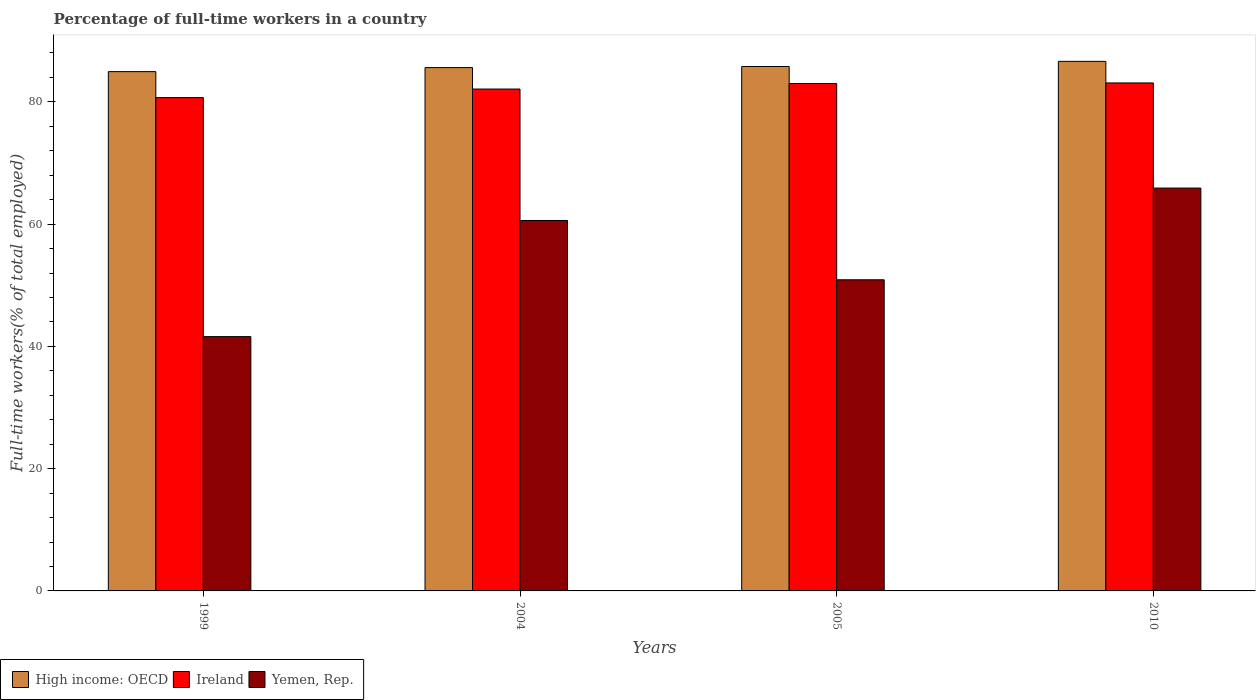How many different coloured bars are there?
Keep it short and to the point. 3. How many groups of bars are there?
Offer a terse response. 4. Are the number of bars on each tick of the X-axis equal?
Offer a terse response. Yes. How many bars are there on the 1st tick from the right?
Keep it short and to the point. 3. In how many cases, is the number of bars for a given year not equal to the number of legend labels?
Offer a terse response. 0. What is the percentage of full-time workers in Ireland in 2004?
Give a very brief answer. 82.1. Across all years, what is the maximum percentage of full-time workers in High income: OECD?
Provide a short and direct response. 86.63. Across all years, what is the minimum percentage of full-time workers in Ireland?
Your answer should be very brief. 80.7. In which year was the percentage of full-time workers in High income: OECD minimum?
Your answer should be compact. 1999. What is the total percentage of full-time workers in Yemen, Rep. in the graph?
Keep it short and to the point. 219. What is the difference between the percentage of full-time workers in Ireland in 1999 and that in 2010?
Offer a terse response. -2.4. What is the difference between the percentage of full-time workers in Ireland in 2005 and the percentage of full-time workers in High income: OECD in 1999?
Provide a succinct answer. -1.95. What is the average percentage of full-time workers in High income: OECD per year?
Offer a very short reply. 85.74. In the year 1999, what is the difference between the percentage of full-time workers in Ireland and percentage of full-time workers in High income: OECD?
Your answer should be very brief. -4.25. In how many years, is the percentage of full-time workers in Ireland greater than 8 %?
Offer a terse response. 4. What is the ratio of the percentage of full-time workers in High income: OECD in 1999 to that in 2010?
Give a very brief answer. 0.98. Is the difference between the percentage of full-time workers in Ireland in 2005 and 2010 greater than the difference between the percentage of full-time workers in High income: OECD in 2005 and 2010?
Your response must be concise. Yes. What is the difference between the highest and the second highest percentage of full-time workers in Ireland?
Provide a short and direct response. 0.1. What is the difference between the highest and the lowest percentage of full-time workers in Yemen, Rep.?
Ensure brevity in your answer.  24.3. What does the 3rd bar from the left in 2010 represents?
Offer a very short reply. Yemen, Rep. What does the 3rd bar from the right in 2005 represents?
Offer a terse response. High income: OECD. What is the difference between two consecutive major ticks on the Y-axis?
Ensure brevity in your answer.  20. Are the values on the major ticks of Y-axis written in scientific E-notation?
Provide a succinct answer. No. Does the graph contain grids?
Ensure brevity in your answer.  No. How are the legend labels stacked?
Keep it short and to the point. Horizontal. What is the title of the graph?
Provide a succinct answer. Percentage of full-time workers in a country. Does "Nicaragua" appear as one of the legend labels in the graph?
Make the answer very short. No. What is the label or title of the X-axis?
Provide a short and direct response. Years. What is the label or title of the Y-axis?
Make the answer very short. Full-time workers(% of total employed). What is the Full-time workers(% of total employed) of High income: OECD in 1999?
Your response must be concise. 84.95. What is the Full-time workers(% of total employed) in Ireland in 1999?
Offer a terse response. 80.7. What is the Full-time workers(% of total employed) in Yemen, Rep. in 1999?
Offer a terse response. 41.6. What is the Full-time workers(% of total employed) in High income: OECD in 2004?
Ensure brevity in your answer.  85.61. What is the Full-time workers(% of total employed) in Ireland in 2004?
Make the answer very short. 82.1. What is the Full-time workers(% of total employed) in Yemen, Rep. in 2004?
Ensure brevity in your answer.  60.6. What is the Full-time workers(% of total employed) in High income: OECD in 2005?
Keep it short and to the point. 85.79. What is the Full-time workers(% of total employed) in Yemen, Rep. in 2005?
Offer a very short reply. 50.9. What is the Full-time workers(% of total employed) in High income: OECD in 2010?
Give a very brief answer. 86.63. What is the Full-time workers(% of total employed) of Ireland in 2010?
Provide a succinct answer. 83.1. What is the Full-time workers(% of total employed) in Yemen, Rep. in 2010?
Your answer should be compact. 65.9. Across all years, what is the maximum Full-time workers(% of total employed) in High income: OECD?
Give a very brief answer. 86.63. Across all years, what is the maximum Full-time workers(% of total employed) of Ireland?
Give a very brief answer. 83.1. Across all years, what is the maximum Full-time workers(% of total employed) of Yemen, Rep.?
Provide a succinct answer. 65.9. Across all years, what is the minimum Full-time workers(% of total employed) in High income: OECD?
Keep it short and to the point. 84.95. Across all years, what is the minimum Full-time workers(% of total employed) of Ireland?
Keep it short and to the point. 80.7. Across all years, what is the minimum Full-time workers(% of total employed) in Yemen, Rep.?
Your response must be concise. 41.6. What is the total Full-time workers(% of total employed) in High income: OECD in the graph?
Provide a short and direct response. 342.97. What is the total Full-time workers(% of total employed) of Ireland in the graph?
Keep it short and to the point. 328.9. What is the total Full-time workers(% of total employed) of Yemen, Rep. in the graph?
Offer a very short reply. 219. What is the difference between the Full-time workers(% of total employed) of High income: OECD in 1999 and that in 2004?
Ensure brevity in your answer.  -0.66. What is the difference between the Full-time workers(% of total employed) of Yemen, Rep. in 1999 and that in 2004?
Your answer should be very brief. -19. What is the difference between the Full-time workers(% of total employed) in High income: OECD in 1999 and that in 2005?
Your response must be concise. -0.84. What is the difference between the Full-time workers(% of total employed) of Ireland in 1999 and that in 2005?
Make the answer very short. -2.3. What is the difference between the Full-time workers(% of total employed) in Yemen, Rep. in 1999 and that in 2005?
Your answer should be very brief. -9.3. What is the difference between the Full-time workers(% of total employed) in High income: OECD in 1999 and that in 2010?
Your answer should be very brief. -1.68. What is the difference between the Full-time workers(% of total employed) in Ireland in 1999 and that in 2010?
Make the answer very short. -2.4. What is the difference between the Full-time workers(% of total employed) in Yemen, Rep. in 1999 and that in 2010?
Your answer should be very brief. -24.3. What is the difference between the Full-time workers(% of total employed) in High income: OECD in 2004 and that in 2005?
Your response must be concise. -0.18. What is the difference between the Full-time workers(% of total employed) of Ireland in 2004 and that in 2005?
Offer a very short reply. -0.9. What is the difference between the Full-time workers(% of total employed) of High income: OECD in 2004 and that in 2010?
Offer a terse response. -1.02. What is the difference between the Full-time workers(% of total employed) of Ireland in 2004 and that in 2010?
Make the answer very short. -1. What is the difference between the Full-time workers(% of total employed) of High income: OECD in 2005 and that in 2010?
Your response must be concise. -0.84. What is the difference between the Full-time workers(% of total employed) of Yemen, Rep. in 2005 and that in 2010?
Your answer should be very brief. -15. What is the difference between the Full-time workers(% of total employed) of High income: OECD in 1999 and the Full-time workers(% of total employed) of Ireland in 2004?
Provide a succinct answer. 2.85. What is the difference between the Full-time workers(% of total employed) in High income: OECD in 1999 and the Full-time workers(% of total employed) in Yemen, Rep. in 2004?
Give a very brief answer. 24.35. What is the difference between the Full-time workers(% of total employed) in Ireland in 1999 and the Full-time workers(% of total employed) in Yemen, Rep. in 2004?
Provide a short and direct response. 20.1. What is the difference between the Full-time workers(% of total employed) in High income: OECD in 1999 and the Full-time workers(% of total employed) in Ireland in 2005?
Offer a very short reply. 1.95. What is the difference between the Full-time workers(% of total employed) of High income: OECD in 1999 and the Full-time workers(% of total employed) of Yemen, Rep. in 2005?
Provide a succinct answer. 34.05. What is the difference between the Full-time workers(% of total employed) in Ireland in 1999 and the Full-time workers(% of total employed) in Yemen, Rep. in 2005?
Your answer should be compact. 29.8. What is the difference between the Full-time workers(% of total employed) of High income: OECD in 1999 and the Full-time workers(% of total employed) of Ireland in 2010?
Your answer should be very brief. 1.85. What is the difference between the Full-time workers(% of total employed) of High income: OECD in 1999 and the Full-time workers(% of total employed) of Yemen, Rep. in 2010?
Provide a short and direct response. 19.05. What is the difference between the Full-time workers(% of total employed) in High income: OECD in 2004 and the Full-time workers(% of total employed) in Ireland in 2005?
Provide a succinct answer. 2.61. What is the difference between the Full-time workers(% of total employed) in High income: OECD in 2004 and the Full-time workers(% of total employed) in Yemen, Rep. in 2005?
Provide a succinct answer. 34.71. What is the difference between the Full-time workers(% of total employed) in Ireland in 2004 and the Full-time workers(% of total employed) in Yemen, Rep. in 2005?
Offer a very short reply. 31.2. What is the difference between the Full-time workers(% of total employed) in High income: OECD in 2004 and the Full-time workers(% of total employed) in Ireland in 2010?
Your answer should be compact. 2.51. What is the difference between the Full-time workers(% of total employed) in High income: OECD in 2004 and the Full-time workers(% of total employed) in Yemen, Rep. in 2010?
Ensure brevity in your answer.  19.71. What is the difference between the Full-time workers(% of total employed) in High income: OECD in 2005 and the Full-time workers(% of total employed) in Ireland in 2010?
Your answer should be compact. 2.69. What is the difference between the Full-time workers(% of total employed) of High income: OECD in 2005 and the Full-time workers(% of total employed) of Yemen, Rep. in 2010?
Your answer should be very brief. 19.89. What is the difference between the Full-time workers(% of total employed) of Ireland in 2005 and the Full-time workers(% of total employed) of Yemen, Rep. in 2010?
Provide a succinct answer. 17.1. What is the average Full-time workers(% of total employed) in High income: OECD per year?
Your answer should be compact. 85.74. What is the average Full-time workers(% of total employed) in Ireland per year?
Offer a very short reply. 82.22. What is the average Full-time workers(% of total employed) in Yemen, Rep. per year?
Offer a terse response. 54.75. In the year 1999, what is the difference between the Full-time workers(% of total employed) in High income: OECD and Full-time workers(% of total employed) in Ireland?
Your answer should be compact. 4.25. In the year 1999, what is the difference between the Full-time workers(% of total employed) in High income: OECD and Full-time workers(% of total employed) in Yemen, Rep.?
Your answer should be compact. 43.35. In the year 1999, what is the difference between the Full-time workers(% of total employed) of Ireland and Full-time workers(% of total employed) of Yemen, Rep.?
Offer a terse response. 39.1. In the year 2004, what is the difference between the Full-time workers(% of total employed) in High income: OECD and Full-time workers(% of total employed) in Ireland?
Offer a very short reply. 3.51. In the year 2004, what is the difference between the Full-time workers(% of total employed) in High income: OECD and Full-time workers(% of total employed) in Yemen, Rep.?
Keep it short and to the point. 25.01. In the year 2004, what is the difference between the Full-time workers(% of total employed) of Ireland and Full-time workers(% of total employed) of Yemen, Rep.?
Offer a terse response. 21.5. In the year 2005, what is the difference between the Full-time workers(% of total employed) in High income: OECD and Full-time workers(% of total employed) in Ireland?
Provide a short and direct response. 2.79. In the year 2005, what is the difference between the Full-time workers(% of total employed) in High income: OECD and Full-time workers(% of total employed) in Yemen, Rep.?
Provide a succinct answer. 34.89. In the year 2005, what is the difference between the Full-time workers(% of total employed) in Ireland and Full-time workers(% of total employed) in Yemen, Rep.?
Provide a short and direct response. 32.1. In the year 2010, what is the difference between the Full-time workers(% of total employed) in High income: OECD and Full-time workers(% of total employed) in Ireland?
Provide a short and direct response. 3.53. In the year 2010, what is the difference between the Full-time workers(% of total employed) in High income: OECD and Full-time workers(% of total employed) in Yemen, Rep.?
Give a very brief answer. 20.73. What is the ratio of the Full-time workers(% of total employed) in High income: OECD in 1999 to that in 2004?
Your answer should be very brief. 0.99. What is the ratio of the Full-time workers(% of total employed) in Ireland in 1999 to that in 2004?
Keep it short and to the point. 0.98. What is the ratio of the Full-time workers(% of total employed) of Yemen, Rep. in 1999 to that in 2004?
Your response must be concise. 0.69. What is the ratio of the Full-time workers(% of total employed) of High income: OECD in 1999 to that in 2005?
Offer a very short reply. 0.99. What is the ratio of the Full-time workers(% of total employed) in Ireland in 1999 to that in 2005?
Ensure brevity in your answer.  0.97. What is the ratio of the Full-time workers(% of total employed) of Yemen, Rep. in 1999 to that in 2005?
Offer a terse response. 0.82. What is the ratio of the Full-time workers(% of total employed) in High income: OECD in 1999 to that in 2010?
Your answer should be very brief. 0.98. What is the ratio of the Full-time workers(% of total employed) of Ireland in 1999 to that in 2010?
Your answer should be compact. 0.97. What is the ratio of the Full-time workers(% of total employed) in Yemen, Rep. in 1999 to that in 2010?
Provide a short and direct response. 0.63. What is the ratio of the Full-time workers(% of total employed) of High income: OECD in 2004 to that in 2005?
Your response must be concise. 1. What is the ratio of the Full-time workers(% of total employed) of Ireland in 2004 to that in 2005?
Your answer should be compact. 0.99. What is the ratio of the Full-time workers(% of total employed) in Yemen, Rep. in 2004 to that in 2005?
Your answer should be very brief. 1.19. What is the ratio of the Full-time workers(% of total employed) in Ireland in 2004 to that in 2010?
Provide a succinct answer. 0.99. What is the ratio of the Full-time workers(% of total employed) in Yemen, Rep. in 2004 to that in 2010?
Provide a succinct answer. 0.92. What is the ratio of the Full-time workers(% of total employed) in High income: OECD in 2005 to that in 2010?
Your answer should be very brief. 0.99. What is the ratio of the Full-time workers(% of total employed) of Ireland in 2005 to that in 2010?
Offer a very short reply. 1. What is the ratio of the Full-time workers(% of total employed) of Yemen, Rep. in 2005 to that in 2010?
Ensure brevity in your answer.  0.77. What is the difference between the highest and the second highest Full-time workers(% of total employed) in High income: OECD?
Offer a terse response. 0.84. What is the difference between the highest and the second highest Full-time workers(% of total employed) in Ireland?
Provide a succinct answer. 0.1. What is the difference between the highest and the second highest Full-time workers(% of total employed) in Yemen, Rep.?
Offer a very short reply. 5.3. What is the difference between the highest and the lowest Full-time workers(% of total employed) of High income: OECD?
Keep it short and to the point. 1.68. What is the difference between the highest and the lowest Full-time workers(% of total employed) of Yemen, Rep.?
Make the answer very short. 24.3. 